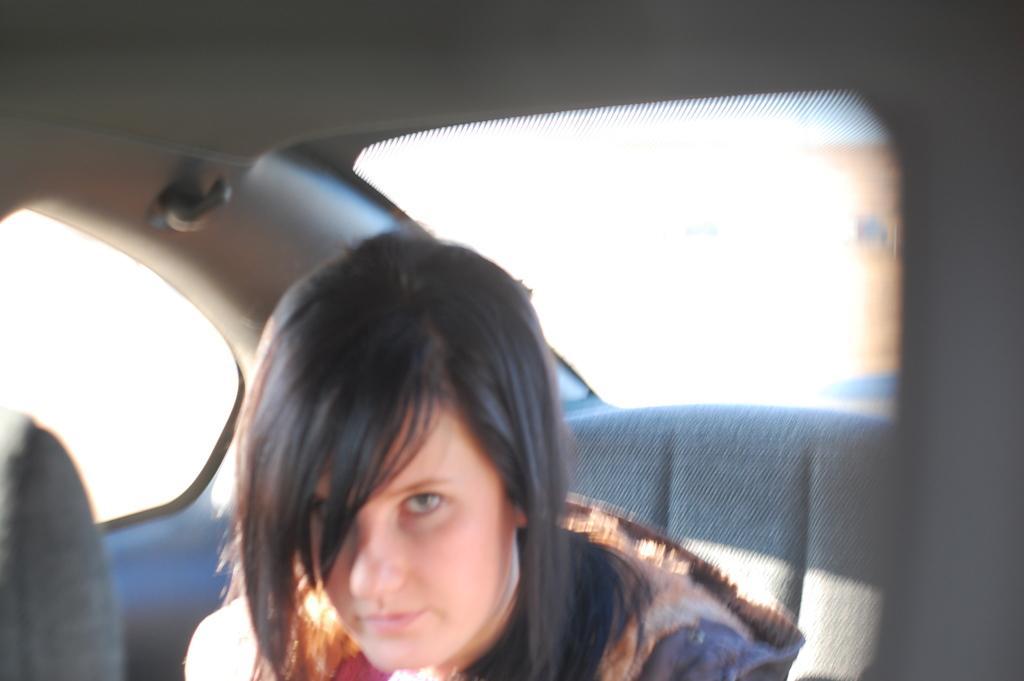Could you give a brief overview of what you see in this image? In this image there is vehicle truncated, there is a person sitting inside a vehicle, the background of the image is white in color. 